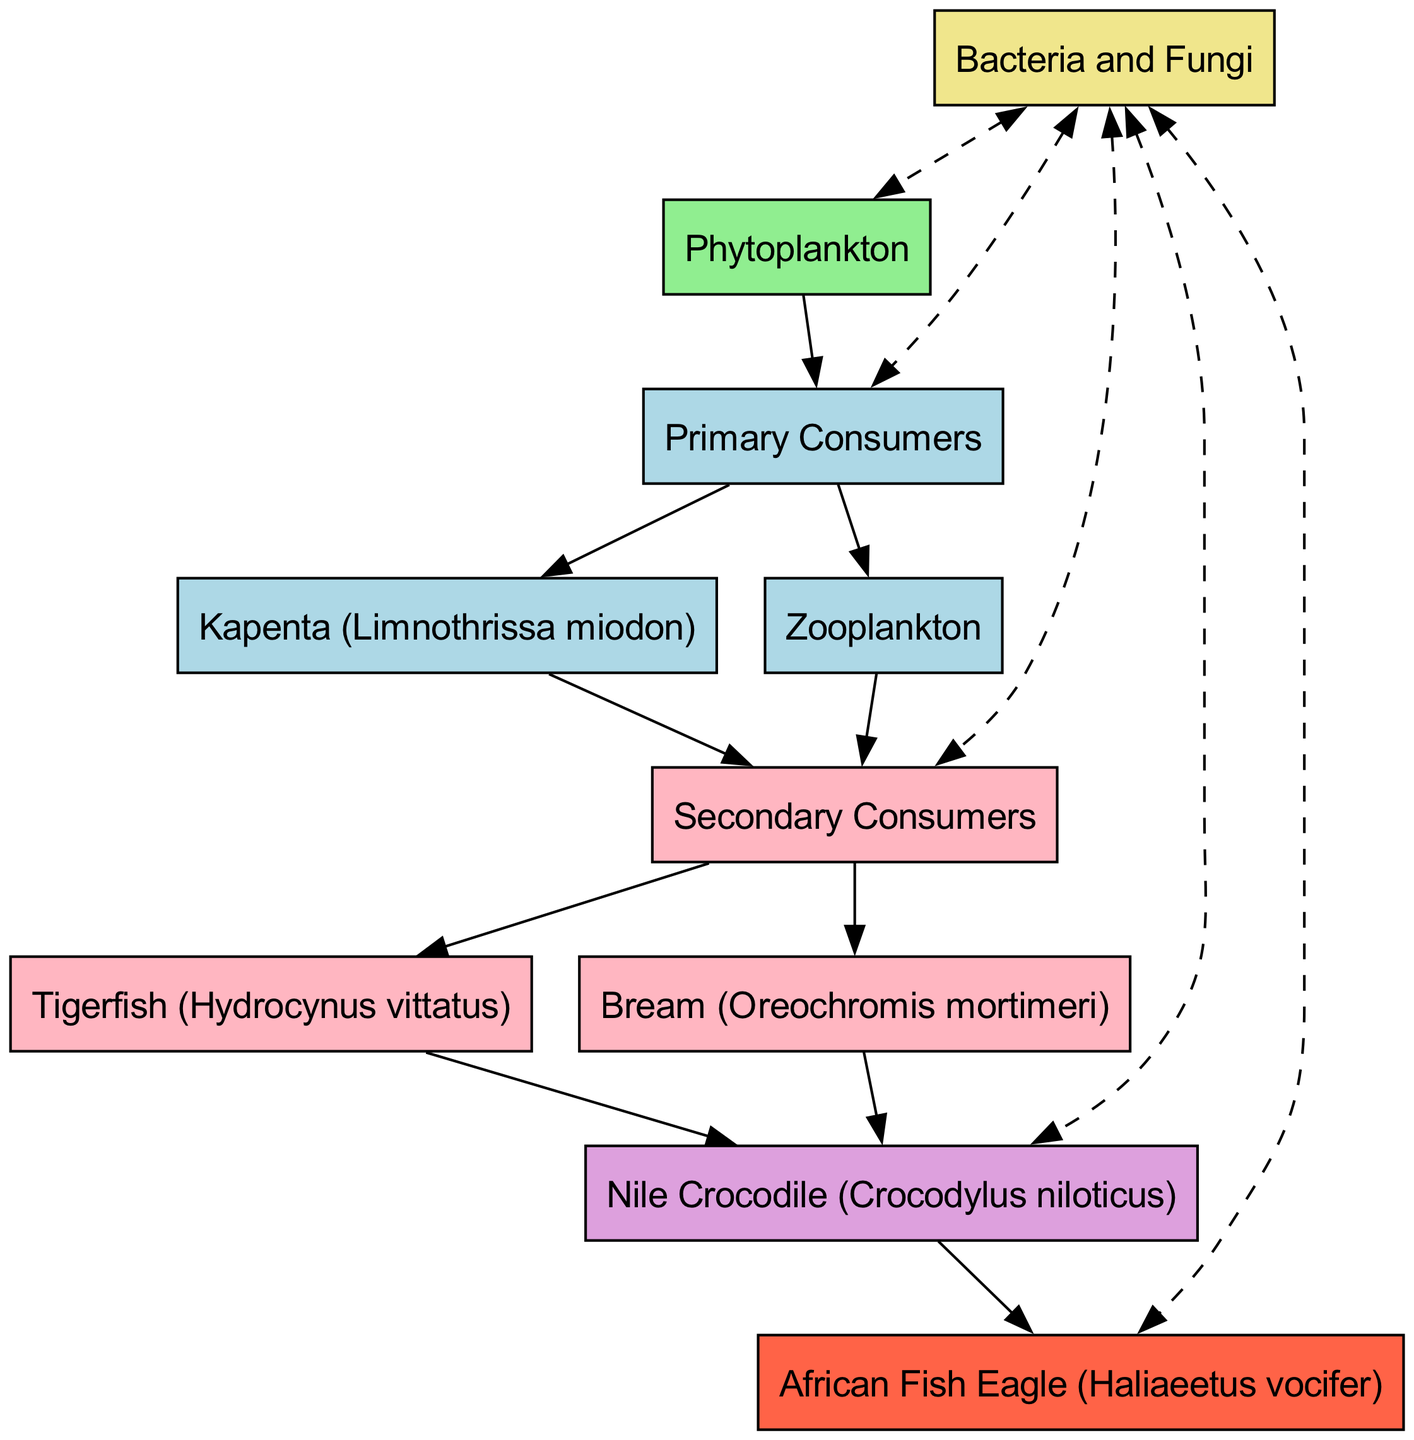What is the producer in the food chain? The producer is the first organism in the food chain and is depicted as a rectangle in the diagram. In this case, it is Phytoplankton, which converts sunlight into energy and forms the base of the aquatic ecosystem.
Answer: Phytoplankton How many primary consumers are there? The primary consumers are listed directly beneath the producer in the diagram. By counting the specific organisms, there are two primary consumers, which are Kapenta and Zooplankton.
Answer: 2 Which consumer is directly eaten by the Nile Crocodile? The Nile Crocodile is a tertiary consumer in the diagram, which means it directly consumes secondary consumers. According to the diagram, it eats both Tigerfish and Bream, but since we need one, we can mention either as the answer.
Answer: Tigerfish What role do Bacteria and Fungi play in the food chain? Bacteria and Fungi are depicted as decomposers in the diagram. They play a crucial role by breaking down dead organisms and returning nutrients to the ecosystem, which is essential for the producers.
Answer: Decomposers Which organism is at the top of the food chain? The apex predator is the organism that sits at the very top of the food chain, meaning it has no natural enemies. In this case, the African Fish Eagle is depicted as the apex predator in the diagram.
Answer: African Fish Eagle How many edges are leading from 'Primary Consumers' to 'Secondary Consumers'? Each primary consumer shown in the diagram contributes to a connection to secondary consumers. Therefore, given there are two primary consumers, each of which is connected to secondary consumers, there are two edges in total leading from 'Primary Consumers' to 'Secondary Consumers'.
Answer: 2 What is the relationship between decomposers and producers in this food chain? The diagram shows that decomposers are connected to producers through bi-directional dashed lines, indicating that decomposers return nutrients back to the producers as they breakdown organic matter. This cycle is essential for the sustainability of the ecosystem.
Answer: Nutrient cycling Which secondary consumer consumes the most energy in this food chain? In the food chain, secondary consumers are the second level of consumers, and they must consume primary consumers to obtain energy. Although the diagram lists both Tigerfish and Bream, the one that typically is known for being more prominent in predation and consumption of energy in aquatic ecosystems is the Tigerfish.
Answer: Tigerfish 